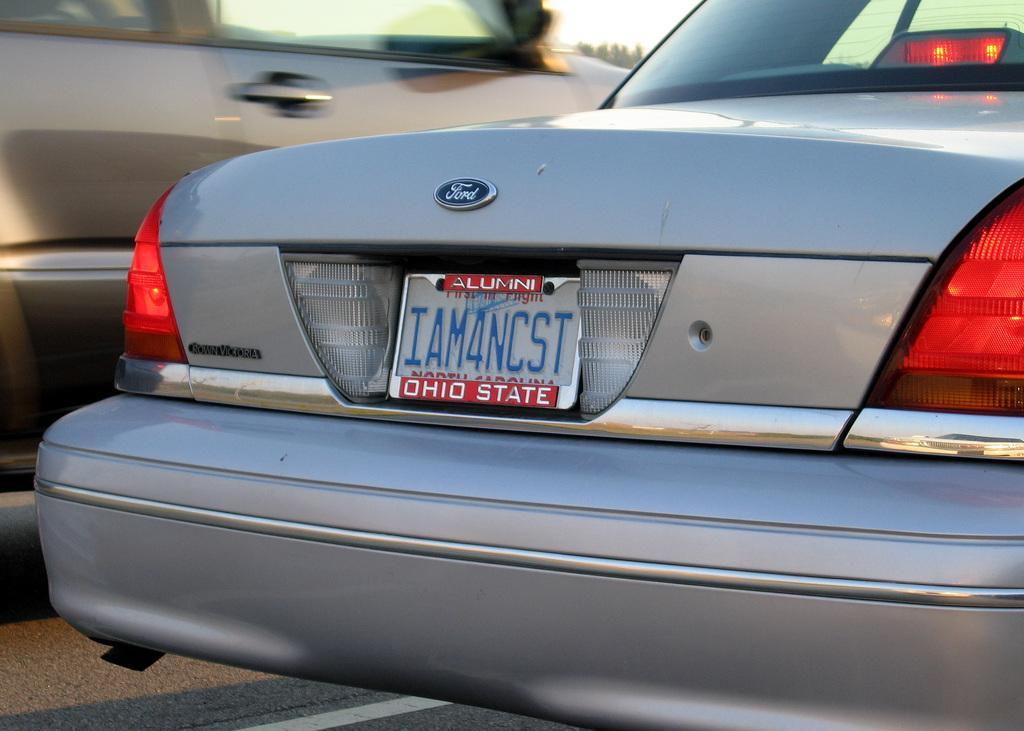Please provide a concise description of this image. In this image, I can see two cars on the road. 